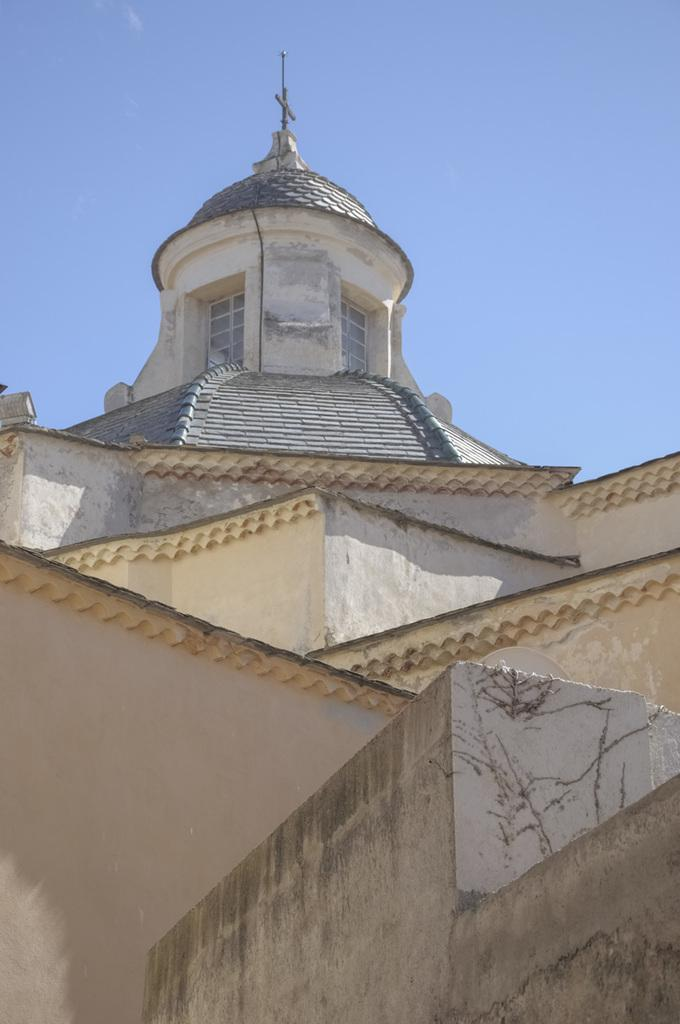What structure is the main subject of the image? There is a building in the image. Are there any specific features on the building? Yes, there is a pole on the building. What can be seen in the background of the image? The sky is visible behind the building. How many oranges are hanging from the pole on the building? There are no oranges present in the image; the pole is on the building, but there are no oranges mentioned or visible. 